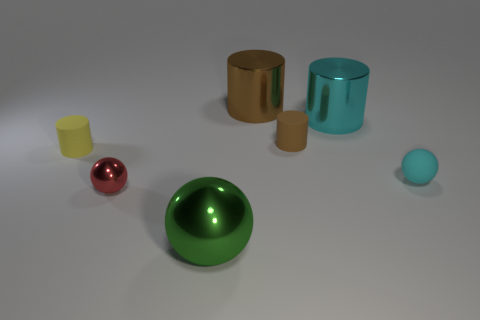Add 3 large cyan metallic things. How many objects exist? 10 Subtract all spheres. How many objects are left? 4 Subtract all big metallic cylinders. Subtract all blue cubes. How many objects are left? 5 Add 7 yellow matte cylinders. How many yellow matte cylinders are left? 8 Add 3 large gray shiny cylinders. How many large gray shiny cylinders exist? 3 Subtract 0 red cylinders. How many objects are left? 7 